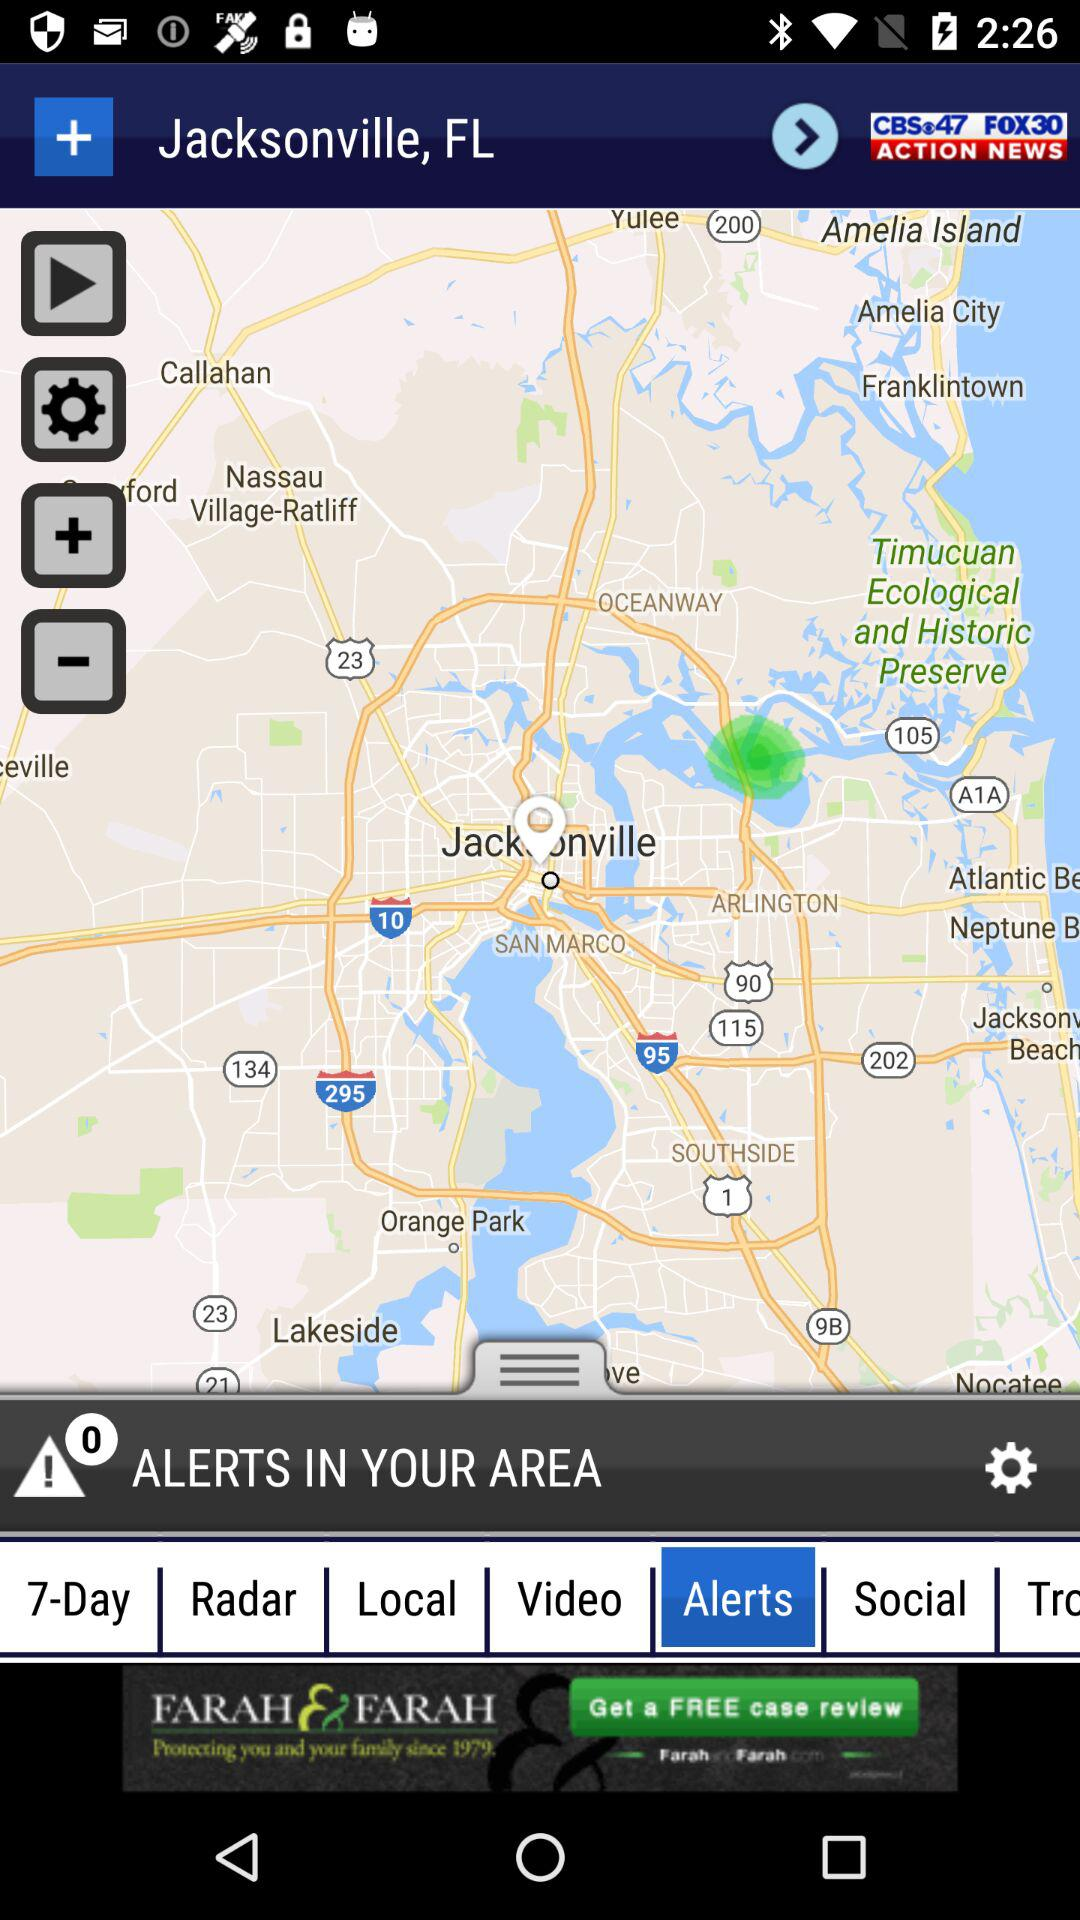How many alerts are there in the area?
Answer the question using a single word or phrase. 0 